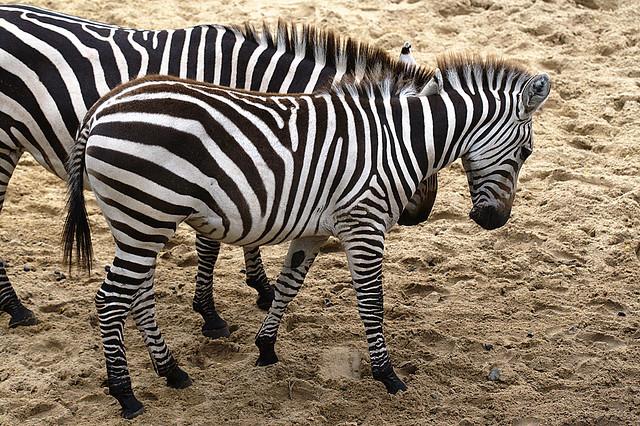How many zebras are there?
Short answer required. 2. Where are the Zebra's are standing?
Quick response, please. Sand. What are the zebra's walking in?
Give a very brief answer. Sand. How many zebras are shown?
Concise answer only. 2. Are there any plants in this picture?
Short answer required. No. 